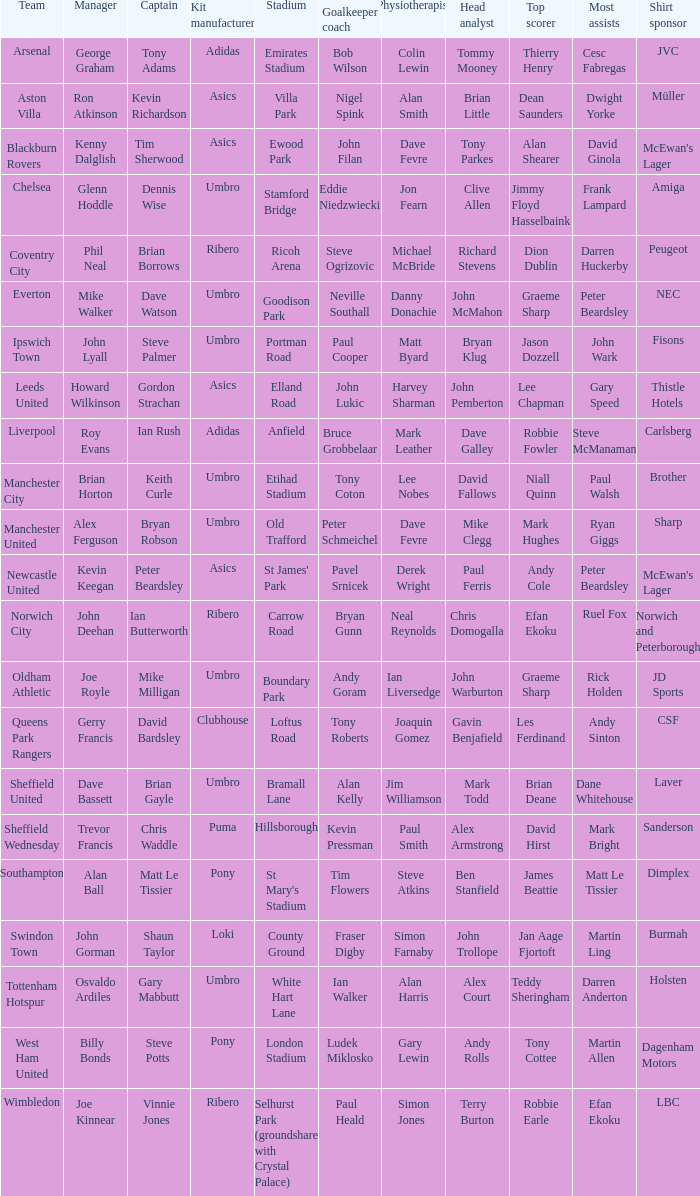Which manager has Manchester City as the team? Brian Horton. 